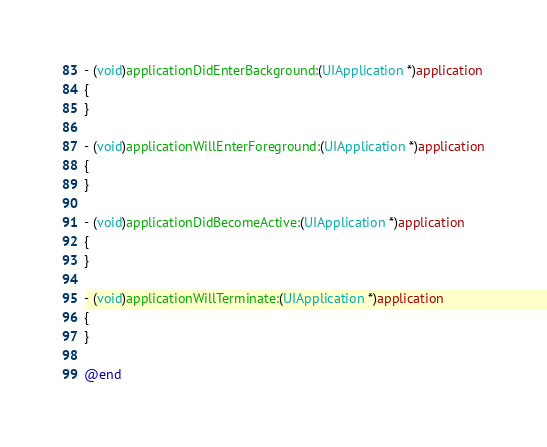Convert code to text. <code><loc_0><loc_0><loc_500><loc_500><_ObjectiveC_>
- (void)applicationDidEnterBackground:(UIApplication *)application
{
}

- (void)applicationWillEnterForeground:(UIApplication *)application
{
}

- (void)applicationDidBecomeActive:(UIApplication *)application
{
}

- (void)applicationWillTerminate:(UIApplication *)application
{
}

@end
</code> 